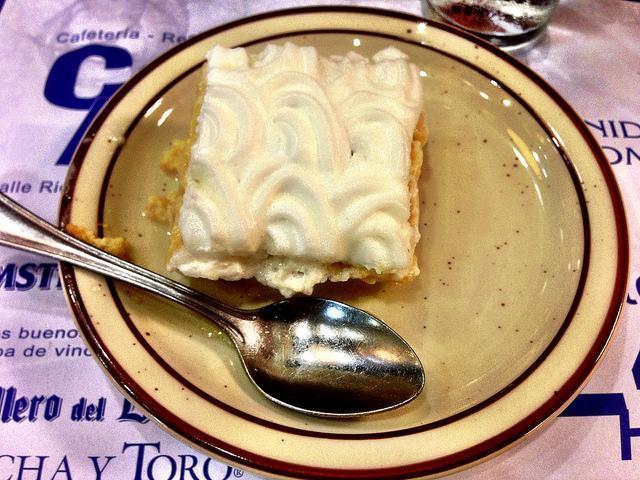What is on the plate?
Make your selection and explain in format: 'Answer: answer
Rationale: rationale.'
Options: Apple, chicken leg, spoon, salmon. Answer: spoon.
Rationale: The plate has a spoon. 